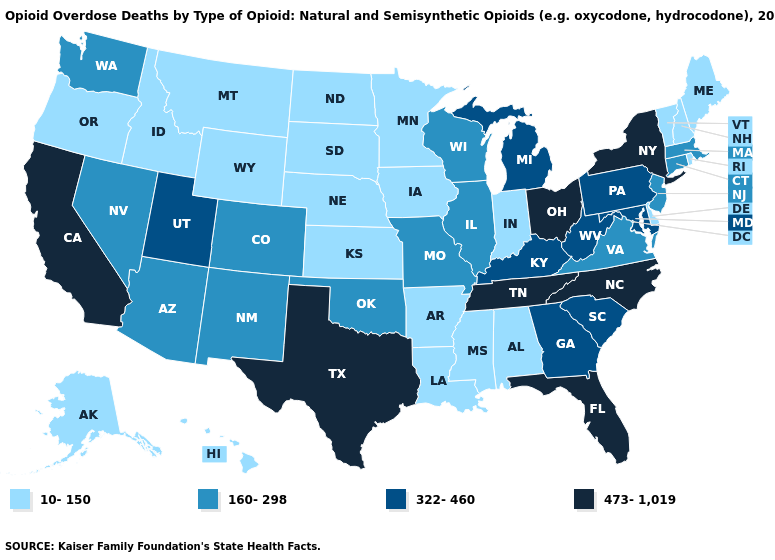Among the states that border Ohio , does Indiana have the lowest value?
Concise answer only. Yes. Name the states that have a value in the range 473-1,019?
Give a very brief answer. California, Florida, New York, North Carolina, Ohio, Tennessee, Texas. Among the states that border Louisiana , does Texas have the highest value?
Give a very brief answer. Yes. Which states have the lowest value in the South?
Give a very brief answer. Alabama, Arkansas, Delaware, Louisiana, Mississippi. What is the lowest value in the USA?
Quick response, please. 10-150. What is the lowest value in the Northeast?
Keep it brief. 10-150. Among the states that border Nevada , which have the lowest value?
Give a very brief answer. Idaho, Oregon. Does Arizona have a higher value than Oregon?
Be succinct. Yes. What is the lowest value in the USA?
Short answer required. 10-150. Among the states that border Mississippi , does Alabama have the highest value?
Give a very brief answer. No. Does Oregon have a higher value than Arizona?
Write a very short answer. No. What is the value of Vermont?
Write a very short answer. 10-150. What is the highest value in the USA?
Short answer required. 473-1,019. What is the value of South Dakota?
Quick response, please. 10-150. What is the value of Hawaii?
Short answer required. 10-150. 